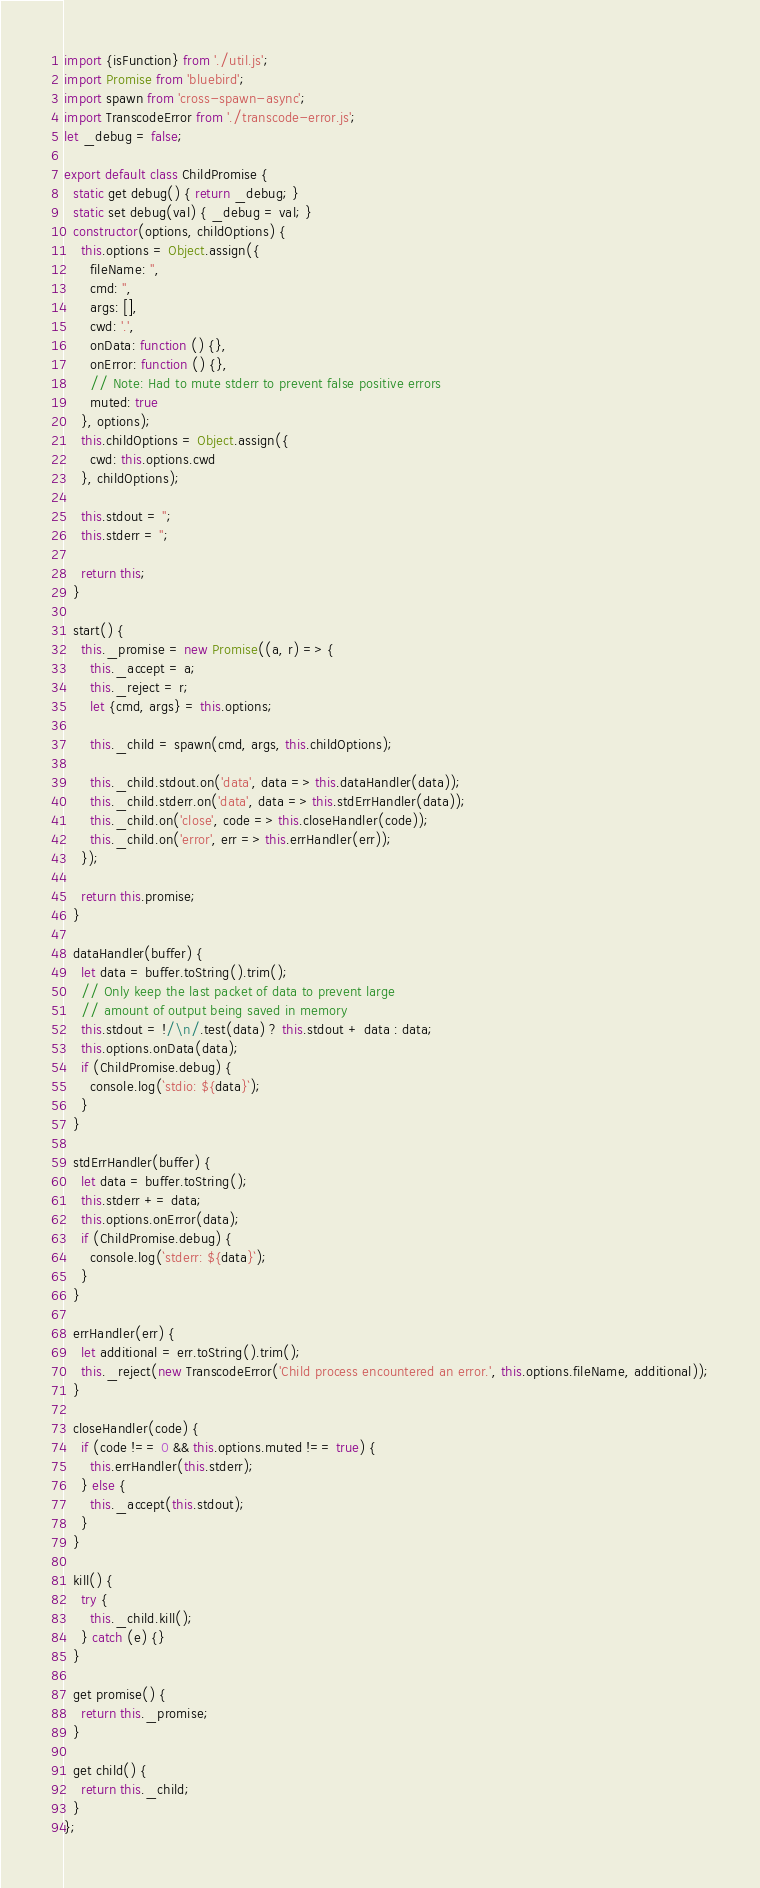<code> <loc_0><loc_0><loc_500><loc_500><_JavaScript_>import {isFunction} from './util.js';
import Promise from 'bluebird';
import spawn from 'cross-spawn-async';
import TranscodeError from './transcode-error.js';
let _debug = false;

export default class ChildPromise {
  static get debug() { return _debug; }
  static set debug(val) { _debug = val; }
  constructor(options, childOptions) {
    this.options = Object.assign({
      fileName: '',
      cmd: '',
      args: [],
      cwd: '.',
      onData: function () {},
      onError: function () {},
      // Note: Had to mute stderr to prevent false positive errors
      muted: true
    }, options);
    this.childOptions = Object.assign({
      cwd: this.options.cwd
    }, childOptions);

    this.stdout = '';
    this.stderr = '';

    return this;
  }

  start() {
    this._promise = new Promise((a, r) => {
      this._accept = a;
      this._reject = r;
      let {cmd, args} = this.options;

      this._child = spawn(cmd, args, this.childOptions);

      this._child.stdout.on('data', data => this.dataHandler(data));
      this._child.stderr.on('data', data => this.stdErrHandler(data));
      this._child.on('close', code => this.closeHandler(code));
      this._child.on('error', err => this.errHandler(err));
    });

    return this.promise;
  }

  dataHandler(buffer) {
    let data = buffer.toString().trim();
    // Only keep the last packet of data to prevent large
    // amount of output being saved in memory
    this.stdout = !/\n/.test(data) ? this.stdout + data : data;
    this.options.onData(data);
    if (ChildPromise.debug) {
      console.log(`stdio: ${data}`);
    }
  }

  stdErrHandler(buffer) {
    let data = buffer.toString();
    this.stderr += data;
    this.options.onError(data);
    if (ChildPromise.debug) {
      console.log(`stderr: ${data}`);
    }
  }

  errHandler(err) {
    let additional = err.toString().trim();
    this._reject(new TranscodeError('Child process encountered an error.', this.options.fileName, additional));
  }

  closeHandler(code) {
    if (code !== 0 && this.options.muted !== true) {
      this.errHandler(this.stderr);
    } else {
      this._accept(this.stdout);
    }
  }

  kill() {
    try {
      this._child.kill();
    } catch (e) {}
  }

  get promise() {
    return this._promise;
  }

  get child() {
    return this._child;
  }
};
</code> 